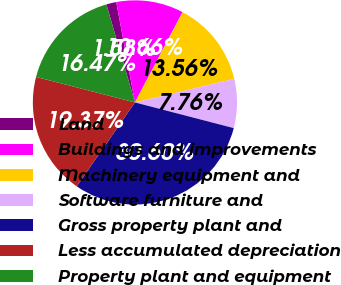<chart> <loc_0><loc_0><loc_500><loc_500><pie_chart><fcel>Land<fcel>Buildings and improvements<fcel>Machinery equipment and<fcel>Software furniture and<fcel>Gross property plant and<fcel>Less accumulated depreciation<fcel>Property plant and equipment<nl><fcel>1.58%<fcel>10.66%<fcel>13.56%<fcel>7.76%<fcel>30.6%<fcel>19.37%<fcel>16.47%<nl></chart> 